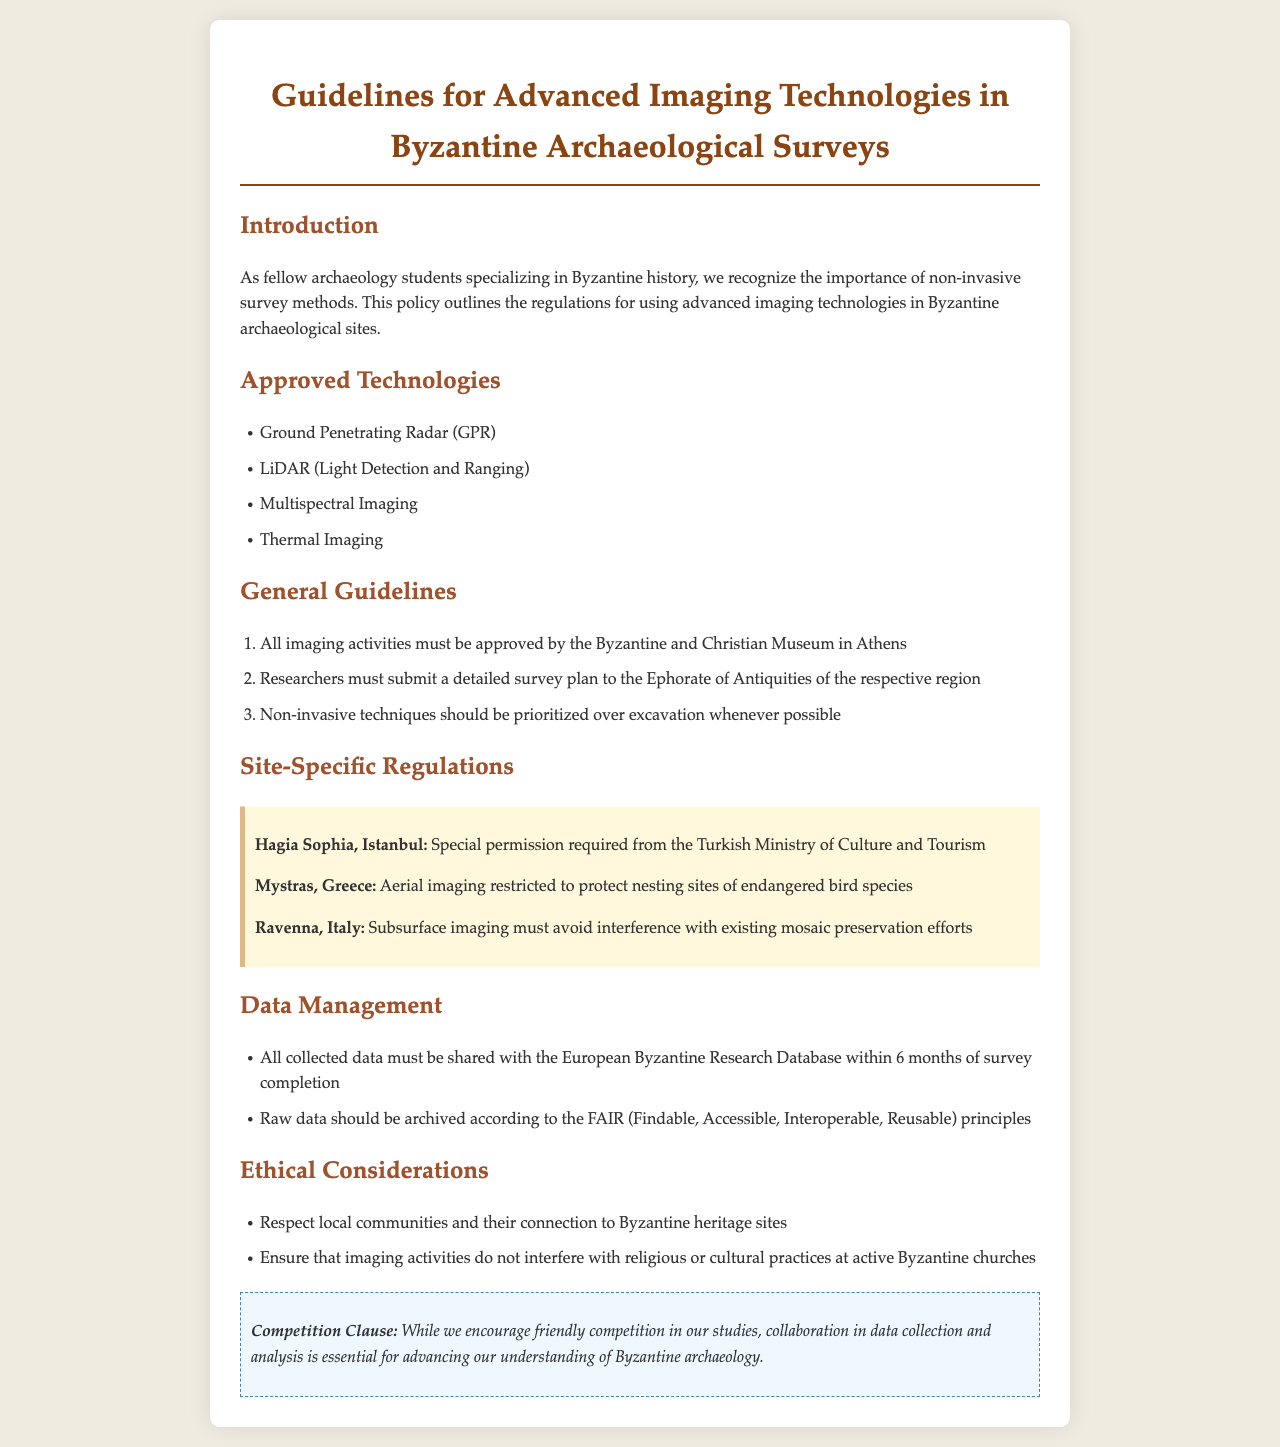What are the approved technologies? The document lists technologies that are permitted for use in Byzantine archaeological surveys, specifically Ground Penetrating Radar, LiDAR, Multispectral Imaging, and Thermal Imaging.
Answer: Ground Penetrating Radar, LiDAR, Multispectral Imaging, Thermal Imaging Who must approve all imaging activities? The guidelines state that the Byzantine and Christian Museum in Athens is responsible for approving all imaging activities conducted at archaeological sites.
Answer: Byzantine and Christian Museum in Athens What is the deadline for sharing collected data? The document specifies a timeframe within which collected data must be shared with the European Byzantine Research Database, which is within 6 months of survey completion.
Answer: 6 months What is required for imaging at Hagia Sophia? Special permission is mandated from a specific authority for imaging activities at Hagia Sophia, indicating a need for regulatory compliance.
Answer: Turkish Ministry of Culture and Tourism What principle should raw data archiving follow? The document mentions that the principles guiding the archiving of raw data are encompassed in the FAIR principles, which enhance usability of the data.
Answer: FAIR (Findable, Accessible, Interoperable, Reusable) Why is collaboration encouraged in the competition clause? The competition clause emphasizes the importance of collaboration in data collection and analysis, as it aids in advancing understanding in the field of Byzantine archaeology.
Answer: Advancing understanding What does the document state about non-invasive techniques? It mentions prioritizing non-invasive techniques over excavation, emphasizing a preference for less intrusive methods in archaeological research.
Answer: Prioritized over excavation What must researchers submit to the Ephorate of Antiquities? A detailed survey plan must be submitted by researchers, as outlined in the general guidelines of the document.
Answer: Detailed survey plan 